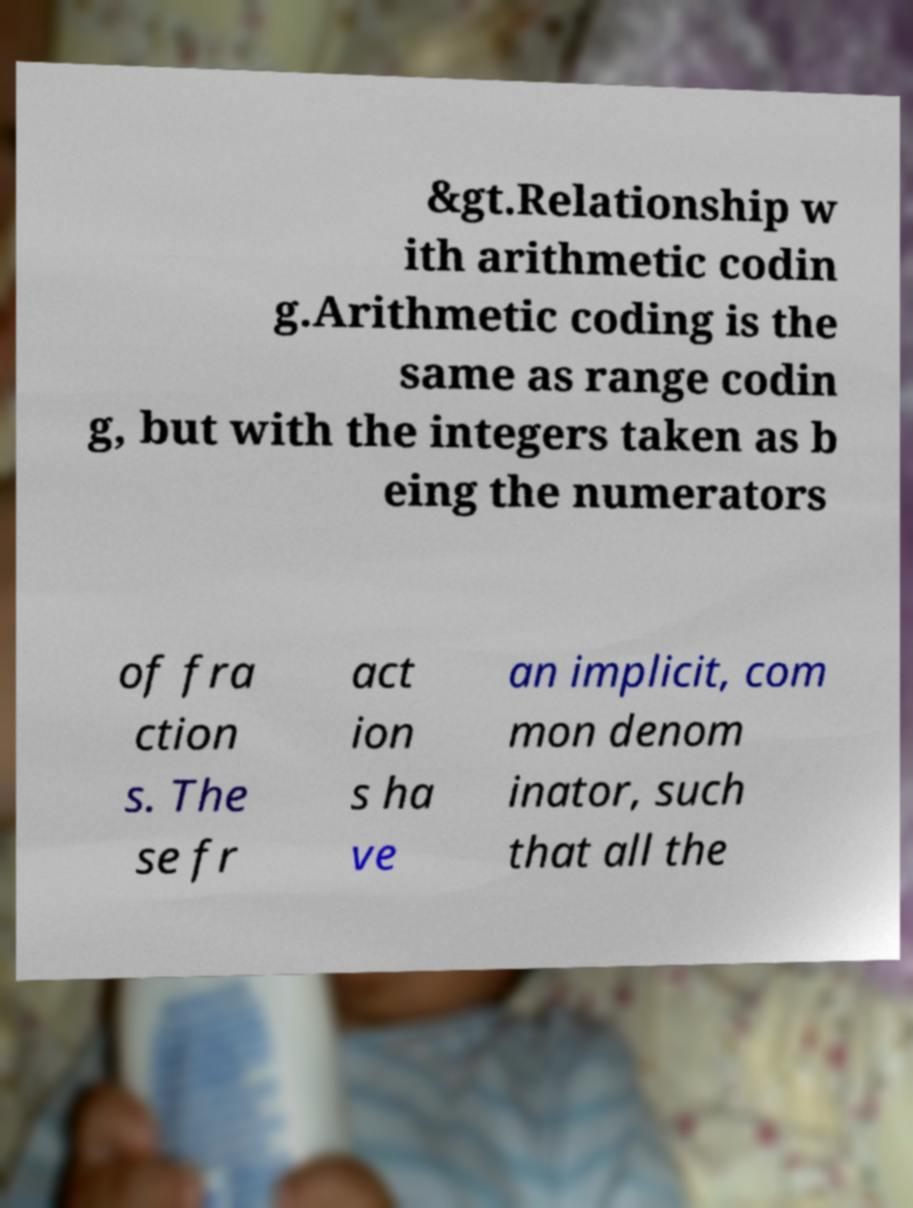What messages or text are displayed in this image? I need them in a readable, typed format. &gt.Relationship w ith arithmetic codin g.Arithmetic coding is the same as range codin g, but with the integers taken as b eing the numerators of fra ction s. The se fr act ion s ha ve an implicit, com mon denom inator, such that all the 